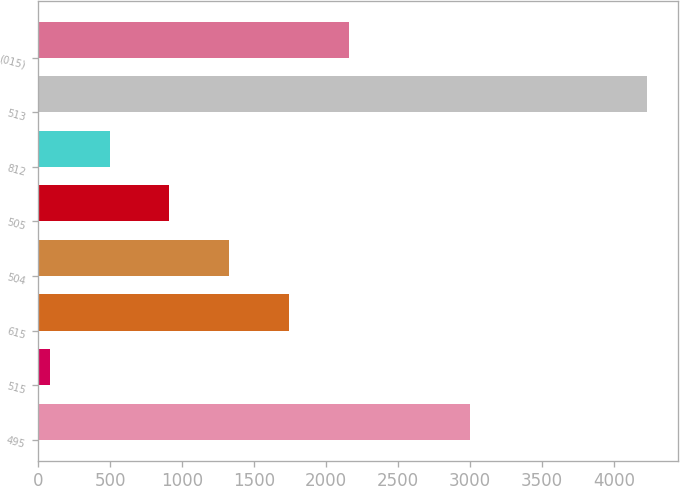<chart> <loc_0><loc_0><loc_500><loc_500><bar_chart><fcel>495<fcel>515<fcel>615<fcel>504<fcel>505<fcel>812<fcel>513<fcel>(015)<nl><fcel>3001<fcel>81<fcel>1740.2<fcel>1325.4<fcel>910.6<fcel>495.8<fcel>4229<fcel>2155<nl></chart> 